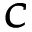<formula> <loc_0><loc_0><loc_500><loc_500>\pm b { C }</formula> 